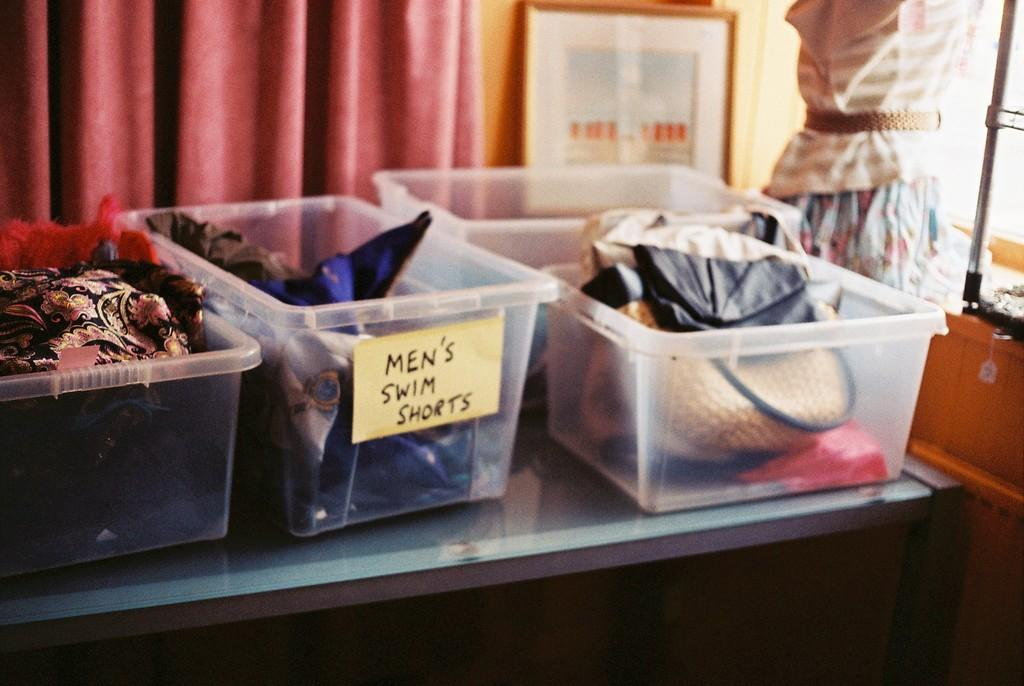<image>
Write a terse but informative summary of the picture. a sticky note on a plastic bin that says Men's swim shorts 